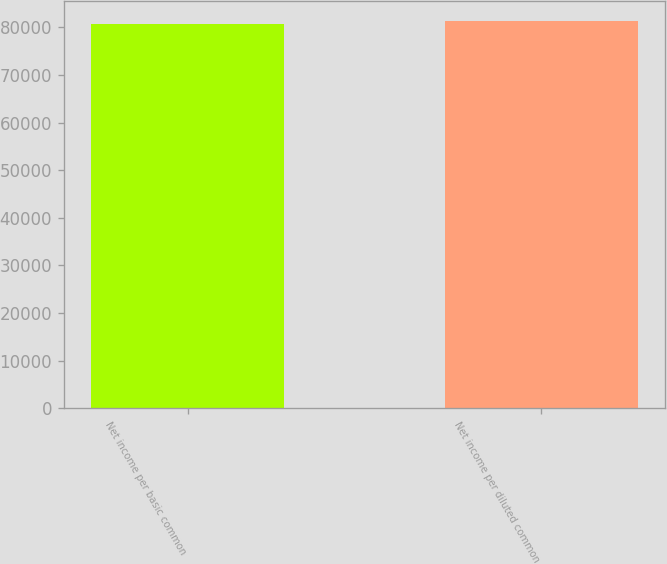Convert chart. <chart><loc_0><loc_0><loc_500><loc_500><bar_chart><fcel>Net income per basic common<fcel>Net income per diluted common<nl><fcel>80786<fcel>81417<nl></chart> 